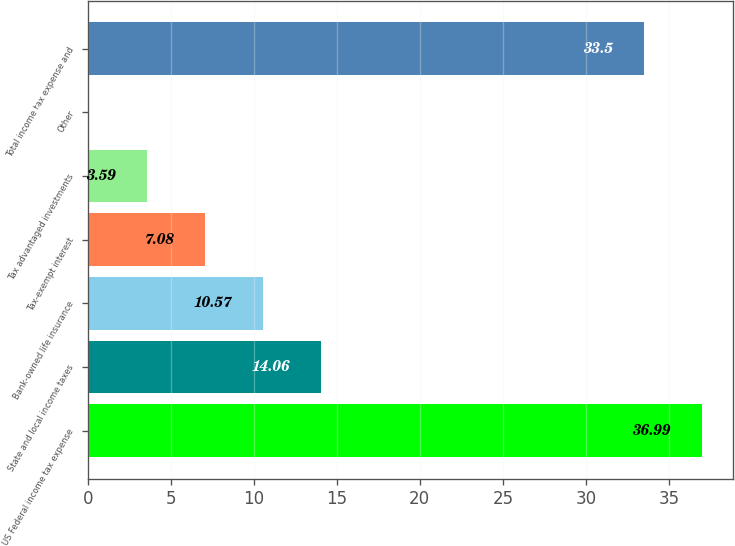Convert chart to OTSL. <chart><loc_0><loc_0><loc_500><loc_500><bar_chart><fcel>US Federal income tax expense<fcel>State and local income taxes<fcel>Bank-owned life insurance<fcel>Tax-exempt interest<fcel>Tax advantaged investments<fcel>Other<fcel>Total income tax expense and<nl><fcel>36.99<fcel>14.06<fcel>10.57<fcel>7.08<fcel>3.59<fcel>0.1<fcel>33.5<nl></chart> 